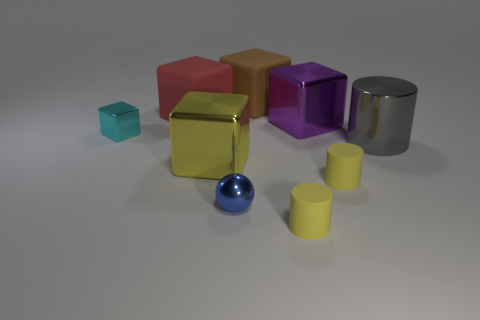Subtract all blue cubes. Subtract all red cylinders. How many cubes are left? 5 Add 1 cyan metallic objects. How many objects exist? 10 Subtract all cylinders. How many objects are left? 6 Subtract all big yellow rubber spheres. Subtract all tiny yellow rubber cylinders. How many objects are left? 7 Add 3 red cubes. How many red cubes are left? 4 Add 7 small purple shiny cylinders. How many small purple shiny cylinders exist? 7 Subtract 0 cyan cylinders. How many objects are left? 9 